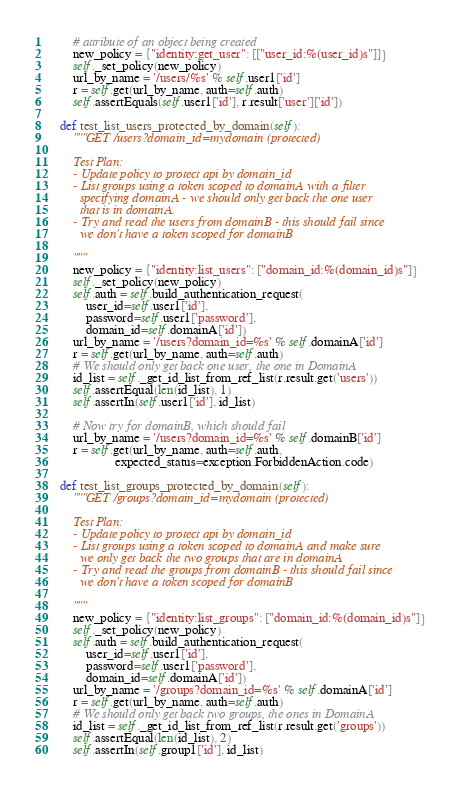Convert code to text. <code><loc_0><loc_0><loc_500><loc_500><_Python_>        # attribute of an object being created
        new_policy = {"identity:get_user": [["user_id:%(user_id)s"]]}
        self._set_policy(new_policy)
        url_by_name = '/users/%s' % self.user1['id']
        r = self.get(url_by_name, auth=self.auth)
        self.assertEquals(self.user1['id'], r.result['user']['id'])

    def test_list_users_protected_by_domain(self):
        """GET /users?domain_id=mydomain (protected)

        Test Plan:
        - Update policy to protect api by domain_id
        - List groups using a token scoped to domainA with a filter
          specifying domainA - we should only get back the one user
          that is in domainA.
        - Try and read the users from domainB - this should fail since
          we don't have a token scoped for domainB

        """
        new_policy = {"identity:list_users": ["domain_id:%(domain_id)s"]}
        self._set_policy(new_policy)
        self.auth = self.build_authentication_request(
            user_id=self.user1['id'],
            password=self.user1['password'],
            domain_id=self.domainA['id'])
        url_by_name = '/users?domain_id=%s' % self.domainA['id']
        r = self.get(url_by_name, auth=self.auth)
        # We should only get back one user, the one in DomainA
        id_list = self._get_id_list_from_ref_list(r.result.get('users'))
        self.assertEqual(len(id_list), 1)
        self.assertIn(self.user1['id'], id_list)

        # Now try for domainB, which should fail
        url_by_name = '/users?domain_id=%s' % self.domainB['id']
        r = self.get(url_by_name, auth=self.auth,
                     expected_status=exception.ForbiddenAction.code)

    def test_list_groups_protected_by_domain(self):
        """GET /groups?domain_id=mydomain (protected)

        Test Plan:
        - Update policy to protect api by domain_id
        - List groups using a token scoped to domainA and make sure
          we only get back the two groups that are in domainA
        - Try and read the groups from domainB - this should fail since
          we don't have a token scoped for domainB

        """
        new_policy = {"identity:list_groups": ["domain_id:%(domain_id)s"]}
        self._set_policy(new_policy)
        self.auth = self.build_authentication_request(
            user_id=self.user1['id'],
            password=self.user1['password'],
            domain_id=self.domainA['id'])
        url_by_name = '/groups?domain_id=%s' % self.domainA['id']
        r = self.get(url_by_name, auth=self.auth)
        # We should only get back two groups, the ones in DomainA
        id_list = self._get_id_list_from_ref_list(r.result.get('groups'))
        self.assertEqual(len(id_list), 2)
        self.assertIn(self.group1['id'], id_list)</code> 